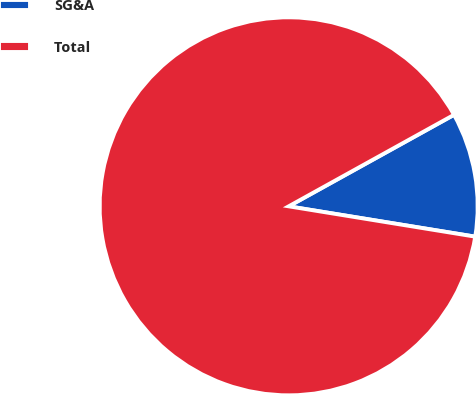Convert chart to OTSL. <chart><loc_0><loc_0><loc_500><loc_500><pie_chart><fcel>SG&A<fcel>Total<nl><fcel>10.61%<fcel>89.39%<nl></chart> 